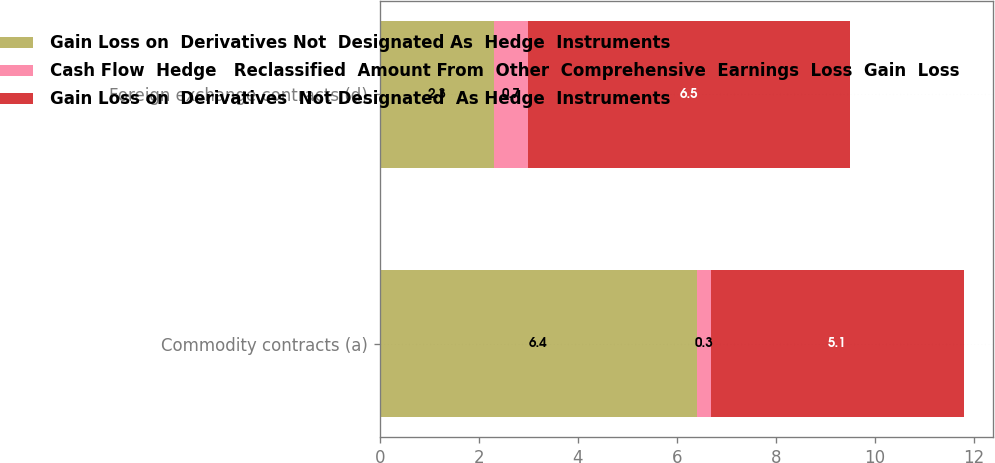Convert chart to OTSL. <chart><loc_0><loc_0><loc_500><loc_500><stacked_bar_chart><ecel><fcel>Commodity contracts (a)<fcel>Foreign exchange contracts (d)<nl><fcel>Gain Loss on  Derivatives Not  Designated As  Hedge  Instruments<fcel>6.4<fcel>2.3<nl><fcel>Cash Flow  Hedge   Reclassified  Amount From  Other  Comprehensive  Earnings  Loss  Gain  Loss<fcel>0.3<fcel>0.7<nl><fcel>Gain Loss on  Derivatives  Not Designated  As Hedge  Instruments<fcel>5.1<fcel>6.5<nl></chart> 